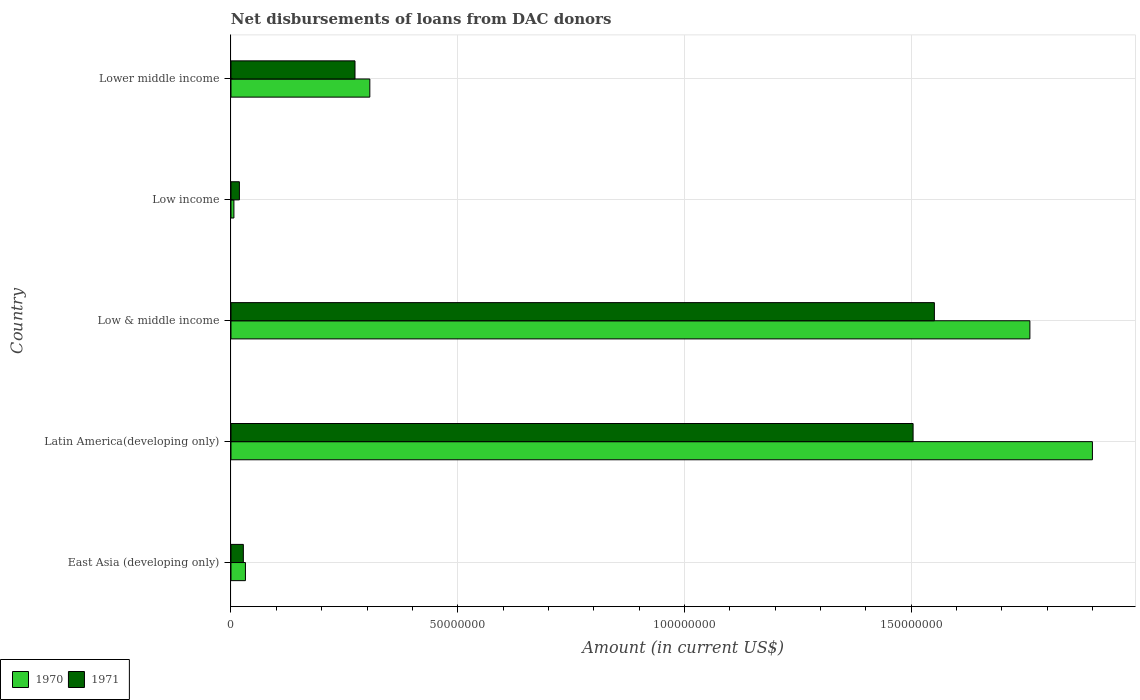How many different coloured bars are there?
Provide a short and direct response. 2. How many groups of bars are there?
Make the answer very short. 5. Are the number of bars per tick equal to the number of legend labels?
Keep it short and to the point. Yes. What is the label of the 5th group of bars from the top?
Give a very brief answer. East Asia (developing only). What is the amount of loans disbursed in 1970 in Latin America(developing only)?
Make the answer very short. 1.90e+08. Across all countries, what is the maximum amount of loans disbursed in 1971?
Give a very brief answer. 1.55e+08. Across all countries, what is the minimum amount of loans disbursed in 1971?
Your response must be concise. 1.86e+06. In which country was the amount of loans disbursed in 1970 maximum?
Your answer should be very brief. Latin America(developing only). In which country was the amount of loans disbursed in 1971 minimum?
Ensure brevity in your answer.  Low income. What is the total amount of loans disbursed in 1971 in the graph?
Offer a terse response. 3.38e+08. What is the difference between the amount of loans disbursed in 1971 in Low income and that in Lower middle income?
Keep it short and to the point. -2.55e+07. What is the difference between the amount of loans disbursed in 1971 in Low income and the amount of loans disbursed in 1970 in East Asia (developing only)?
Your answer should be compact. -1.33e+06. What is the average amount of loans disbursed in 1970 per country?
Offer a terse response. 8.01e+07. What is the difference between the amount of loans disbursed in 1970 and amount of loans disbursed in 1971 in Low & middle income?
Your response must be concise. 2.11e+07. What is the ratio of the amount of loans disbursed in 1971 in Low & middle income to that in Lower middle income?
Your response must be concise. 5.67. Is the difference between the amount of loans disbursed in 1970 in Latin America(developing only) and Lower middle income greater than the difference between the amount of loans disbursed in 1971 in Latin America(developing only) and Lower middle income?
Your answer should be very brief. Yes. What is the difference between the highest and the second highest amount of loans disbursed in 1971?
Ensure brevity in your answer.  4.69e+06. What is the difference between the highest and the lowest amount of loans disbursed in 1971?
Give a very brief answer. 1.53e+08. Is the sum of the amount of loans disbursed in 1970 in Low & middle income and Lower middle income greater than the maximum amount of loans disbursed in 1971 across all countries?
Offer a very short reply. Yes. What does the 1st bar from the bottom in Low income represents?
Offer a very short reply. 1970. How many bars are there?
Keep it short and to the point. 10. Are all the bars in the graph horizontal?
Offer a very short reply. Yes. What is the difference between two consecutive major ticks on the X-axis?
Provide a succinct answer. 5.00e+07. Are the values on the major ticks of X-axis written in scientific E-notation?
Give a very brief answer. No. Does the graph contain any zero values?
Make the answer very short. No. Where does the legend appear in the graph?
Make the answer very short. Bottom left. How many legend labels are there?
Your response must be concise. 2. How are the legend labels stacked?
Make the answer very short. Horizontal. What is the title of the graph?
Your response must be concise. Net disbursements of loans from DAC donors. What is the Amount (in current US$) of 1970 in East Asia (developing only)?
Offer a terse response. 3.19e+06. What is the Amount (in current US$) in 1971 in East Asia (developing only)?
Make the answer very short. 2.73e+06. What is the Amount (in current US$) of 1970 in Latin America(developing only)?
Give a very brief answer. 1.90e+08. What is the Amount (in current US$) in 1971 in Latin America(developing only)?
Provide a succinct answer. 1.50e+08. What is the Amount (in current US$) of 1970 in Low & middle income?
Your answer should be compact. 1.76e+08. What is the Amount (in current US$) in 1971 in Low & middle income?
Ensure brevity in your answer.  1.55e+08. What is the Amount (in current US$) of 1970 in Low income?
Give a very brief answer. 6.47e+05. What is the Amount (in current US$) of 1971 in Low income?
Provide a short and direct response. 1.86e+06. What is the Amount (in current US$) of 1970 in Lower middle income?
Your answer should be compact. 3.06e+07. What is the Amount (in current US$) of 1971 in Lower middle income?
Your response must be concise. 2.74e+07. Across all countries, what is the maximum Amount (in current US$) of 1970?
Offer a terse response. 1.90e+08. Across all countries, what is the maximum Amount (in current US$) of 1971?
Your answer should be compact. 1.55e+08. Across all countries, what is the minimum Amount (in current US$) in 1970?
Offer a very short reply. 6.47e+05. Across all countries, what is the minimum Amount (in current US$) in 1971?
Provide a succinct answer. 1.86e+06. What is the total Amount (in current US$) in 1970 in the graph?
Provide a short and direct response. 4.01e+08. What is the total Amount (in current US$) of 1971 in the graph?
Your answer should be compact. 3.38e+08. What is the difference between the Amount (in current US$) of 1970 in East Asia (developing only) and that in Latin America(developing only)?
Offer a terse response. -1.87e+08. What is the difference between the Amount (in current US$) of 1971 in East Asia (developing only) and that in Latin America(developing only)?
Offer a very short reply. -1.48e+08. What is the difference between the Amount (in current US$) in 1970 in East Asia (developing only) and that in Low & middle income?
Offer a terse response. -1.73e+08. What is the difference between the Amount (in current US$) of 1971 in East Asia (developing only) and that in Low & middle income?
Provide a short and direct response. -1.52e+08. What is the difference between the Amount (in current US$) of 1970 in East Asia (developing only) and that in Low income?
Ensure brevity in your answer.  2.54e+06. What is the difference between the Amount (in current US$) of 1971 in East Asia (developing only) and that in Low income?
Provide a short and direct response. 8.69e+05. What is the difference between the Amount (in current US$) of 1970 in East Asia (developing only) and that in Lower middle income?
Give a very brief answer. -2.74e+07. What is the difference between the Amount (in current US$) in 1971 in East Asia (developing only) and that in Lower middle income?
Give a very brief answer. -2.46e+07. What is the difference between the Amount (in current US$) of 1970 in Latin America(developing only) and that in Low & middle income?
Give a very brief answer. 1.38e+07. What is the difference between the Amount (in current US$) in 1971 in Latin America(developing only) and that in Low & middle income?
Ensure brevity in your answer.  -4.69e+06. What is the difference between the Amount (in current US$) of 1970 in Latin America(developing only) and that in Low income?
Keep it short and to the point. 1.89e+08. What is the difference between the Amount (in current US$) in 1971 in Latin America(developing only) and that in Low income?
Keep it short and to the point. 1.49e+08. What is the difference between the Amount (in current US$) of 1970 in Latin America(developing only) and that in Lower middle income?
Offer a terse response. 1.59e+08. What is the difference between the Amount (in current US$) in 1971 in Latin America(developing only) and that in Lower middle income?
Your answer should be very brief. 1.23e+08. What is the difference between the Amount (in current US$) in 1970 in Low & middle income and that in Low income?
Offer a terse response. 1.76e+08. What is the difference between the Amount (in current US$) of 1971 in Low & middle income and that in Low income?
Your response must be concise. 1.53e+08. What is the difference between the Amount (in current US$) in 1970 in Low & middle income and that in Lower middle income?
Keep it short and to the point. 1.46e+08. What is the difference between the Amount (in current US$) of 1971 in Low & middle income and that in Lower middle income?
Your answer should be very brief. 1.28e+08. What is the difference between the Amount (in current US$) of 1970 in Low income and that in Lower middle income?
Provide a succinct answer. -3.00e+07. What is the difference between the Amount (in current US$) of 1971 in Low income and that in Lower middle income?
Make the answer very short. -2.55e+07. What is the difference between the Amount (in current US$) in 1970 in East Asia (developing only) and the Amount (in current US$) in 1971 in Latin America(developing only)?
Offer a terse response. -1.47e+08. What is the difference between the Amount (in current US$) of 1970 in East Asia (developing only) and the Amount (in current US$) of 1971 in Low & middle income?
Provide a short and direct response. -1.52e+08. What is the difference between the Amount (in current US$) in 1970 in East Asia (developing only) and the Amount (in current US$) in 1971 in Low income?
Give a very brief answer. 1.33e+06. What is the difference between the Amount (in current US$) of 1970 in East Asia (developing only) and the Amount (in current US$) of 1971 in Lower middle income?
Your answer should be compact. -2.42e+07. What is the difference between the Amount (in current US$) of 1970 in Latin America(developing only) and the Amount (in current US$) of 1971 in Low & middle income?
Give a very brief answer. 3.49e+07. What is the difference between the Amount (in current US$) of 1970 in Latin America(developing only) and the Amount (in current US$) of 1971 in Low income?
Keep it short and to the point. 1.88e+08. What is the difference between the Amount (in current US$) of 1970 in Latin America(developing only) and the Amount (in current US$) of 1971 in Lower middle income?
Provide a short and direct response. 1.63e+08. What is the difference between the Amount (in current US$) of 1970 in Low & middle income and the Amount (in current US$) of 1971 in Low income?
Your answer should be compact. 1.74e+08. What is the difference between the Amount (in current US$) of 1970 in Low & middle income and the Amount (in current US$) of 1971 in Lower middle income?
Provide a short and direct response. 1.49e+08. What is the difference between the Amount (in current US$) in 1970 in Low income and the Amount (in current US$) in 1971 in Lower middle income?
Your response must be concise. -2.67e+07. What is the average Amount (in current US$) in 1970 per country?
Provide a short and direct response. 8.01e+07. What is the average Amount (in current US$) of 1971 per country?
Your response must be concise. 6.75e+07. What is the difference between the Amount (in current US$) in 1970 and Amount (in current US$) in 1971 in East Asia (developing only)?
Offer a very short reply. 4.61e+05. What is the difference between the Amount (in current US$) in 1970 and Amount (in current US$) in 1971 in Latin America(developing only)?
Provide a succinct answer. 3.96e+07. What is the difference between the Amount (in current US$) in 1970 and Amount (in current US$) in 1971 in Low & middle income?
Your answer should be very brief. 2.11e+07. What is the difference between the Amount (in current US$) of 1970 and Amount (in current US$) of 1971 in Low income?
Keep it short and to the point. -1.21e+06. What is the difference between the Amount (in current US$) in 1970 and Amount (in current US$) in 1971 in Lower middle income?
Ensure brevity in your answer.  3.27e+06. What is the ratio of the Amount (in current US$) in 1970 in East Asia (developing only) to that in Latin America(developing only)?
Provide a succinct answer. 0.02. What is the ratio of the Amount (in current US$) of 1971 in East Asia (developing only) to that in Latin America(developing only)?
Offer a very short reply. 0.02. What is the ratio of the Amount (in current US$) in 1970 in East Asia (developing only) to that in Low & middle income?
Give a very brief answer. 0.02. What is the ratio of the Amount (in current US$) of 1971 in East Asia (developing only) to that in Low & middle income?
Offer a terse response. 0.02. What is the ratio of the Amount (in current US$) in 1970 in East Asia (developing only) to that in Low income?
Provide a succinct answer. 4.93. What is the ratio of the Amount (in current US$) in 1971 in East Asia (developing only) to that in Low income?
Give a very brief answer. 1.47. What is the ratio of the Amount (in current US$) in 1970 in East Asia (developing only) to that in Lower middle income?
Provide a succinct answer. 0.1. What is the ratio of the Amount (in current US$) in 1971 in East Asia (developing only) to that in Lower middle income?
Your response must be concise. 0.1. What is the ratio of the Amount (in current US$) of 1970 in Latin America(developing only) to that in Low & middle income?
Provide a succinct answer. 1.08. What is the ratio of the Amount (in current US$) of 1971 in Latin America(developing only) to that in Low & middle income?
Ensure brevity in your answer.  0.97. What is the ratio of the Amount (in current US$) of 1970 in Latin America(developing only) to that in Low income?
Offer a very short reply. 293.65. What is the ratio of the Amount (in current US$) of 1971 in Latin America(developing only) to that in Low income?
Give a very brief answer. 80.93. What is the ratio of the Amount (in current US$) of 1970 in Latin America(developing only) to that in Lower middle income?
Your response must be concise. 6.2. What is the ratio of the Amount (in current US$) of 1971 in Latin America(developing only) to that in Lower middle income?
Provide a short and direct response. 5.5. What is the ratio of the Amount (in current US$) in 1970 in Low & middle income to that in Low income?
Provide a short and direct response. 272.33. What is the ratio of the Amount (in current US$) in 1971 in Low & middle income to that in Low income?
Offer a very short reply. 83.45. What is the ratio of the Amount (in current US$) in 1970 in Low & middle income to that in Lower middle income?
Provide a short and direct response. 5.75. What is the ratio of the Amount (in current US$) in 1971 in Low & middle income to that in Lower middle income?
Your answer should be very brief. 5.67. What is the ratio of the Amount (in current US$) in 1970 in Low income to that in Lower middle income?
Provide a short and direct response. 0.02. What is the ratio of the Amount (in current US$) of 1971 in Low income to that in Lower middle income?
Your answer should be compact. 0.07. What is the difference between the highest and the second highest Amount (in current US$) in 1970?
Provide a succinct answer. 1.38e+07. What is the difference between the highest and the second highest Amount (in current US$) of 1971?
Offer a very short reply. 4.69e+06. What is the difference between the highest and the lowest Amount (in current US$) in 1970?
Your response must be concise. 1.89e+08. What is the difference between the highest and the lowest Amount (in current US$) of 1971?
Keep it short and to the point. 1.53e+08. 